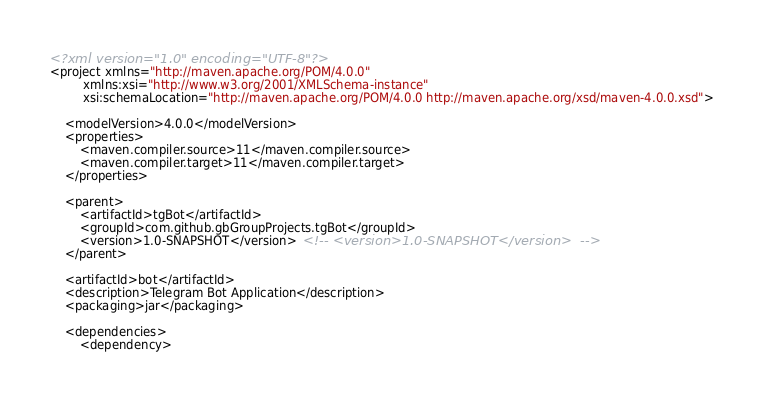<code> <loc_0><loc_0><loc_500><loc_500><_XML_><?xml version="1.0" encoding="UTF-8"?>
<project xmlns="http://maven.apache.org/POM/4.0.0"
         xmlns:xsi="http://www.w3.org/2001/XMLSchema-instance"
         xsi:schemaLocation="http://maven.apache.org/POM/4.0.0 http://maven.apache.org/xsd/maven-4.0.0.xsd">

    <modelVersion>4.0.0</modelVersion>
    <properties>
        <maven.compiler.source>11</maven.compiler.source>
        <maven.compiler.target>11</maven.compiler.target>
    </properties>

    <parent>
        <artifactId>tgBot</artifactId>
	    <groupId>com.github.gbGroupProjects.tgBot</groupId>
        <version>1.0-SNAPSHOT</version>  <!-- <version>1.0-SNAPSHOT</version>  -->
    </parent>

    <artifactId>bot</artifactId>
    <description>Telegram Bot Application</description>
    <packaging>jar</packaging>

    <dependencies>
        <dependency></code> 